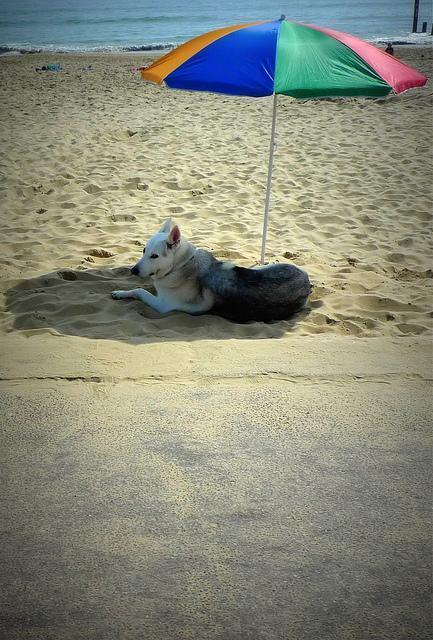How many green cars are there?
Give a very brief answer. 0. 